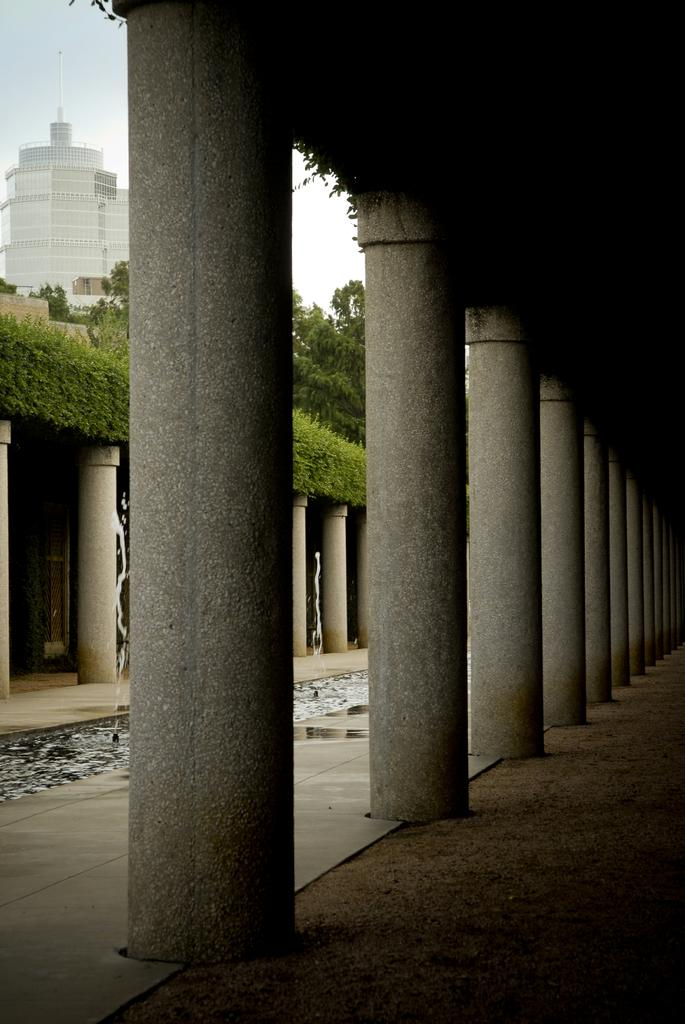What is located in the center of the image? There is a series of pillars in the center of the image. What can be seen on the left side of the image? There is a building, trees, plants, pillars, and water on the left side of the image. What is visible in the background of the image? The sky is visible in the background of the image. What time of day is it on the farm in the image? There is no farm present in the image, and therefore no specific time of day can be determined. How many geese are visible in the image? There are no geese present in the image. 